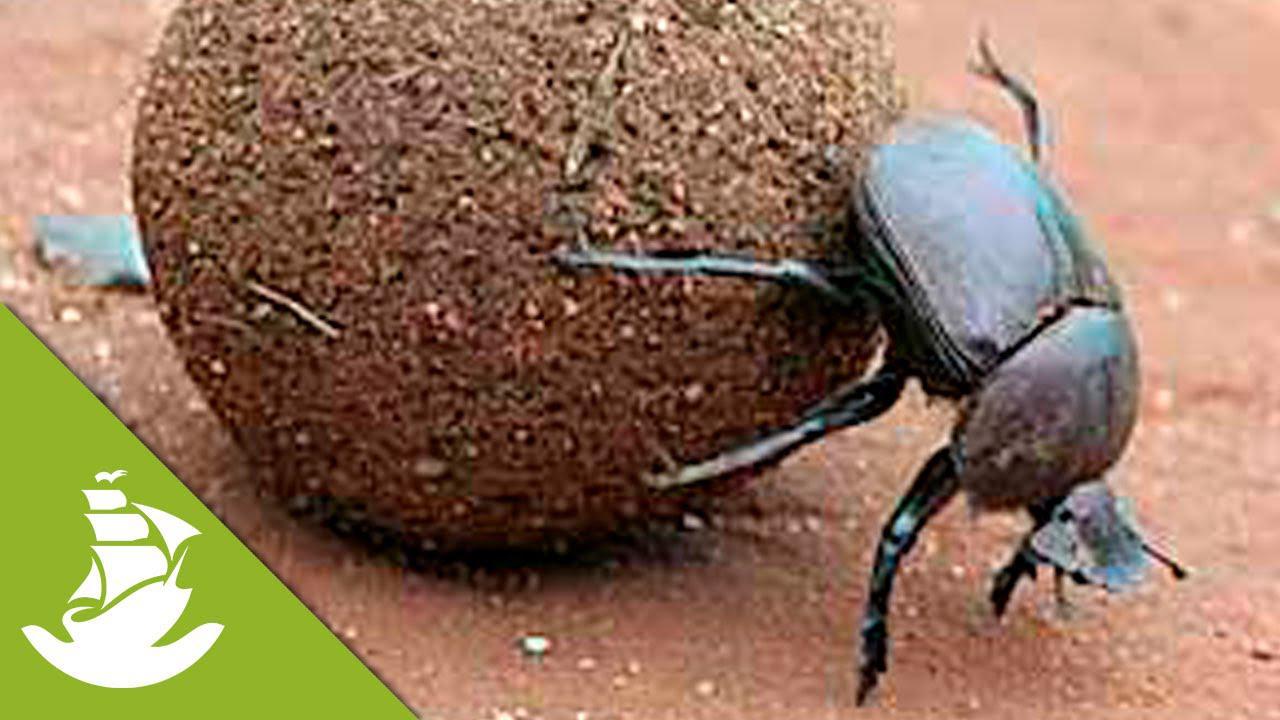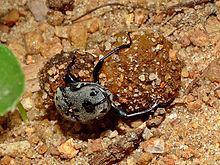The first image is the image on the left, the second image is the image on the right. Assess this claim about the two images: "One image features two beetles on opposite sides of a dung ball.". Correct or not? Answer yes or no. No. The first image is the image on the left, the second image is the image on the right. Examine the images to the left and right. Is the description "The beetle in the image on the left is sitting on top the clod of dirt." accurate? Answer yes or no. No. The first image is the image on the left, the second image is the image on the right. Examine the images to the left and right. Is the description "Two beetles are shown with a ball of dirt in one of the images." accurate? Answer yes or no. No. The first image is the image on the left, the second image is the image on the right. For the images shown, is this caption "The photos contain a total of three beetles." true? Answer yes or no. No. 